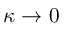<formula> <loc_0><loc_0><loc_500><loc_500>\kappa \to 0</formula> 